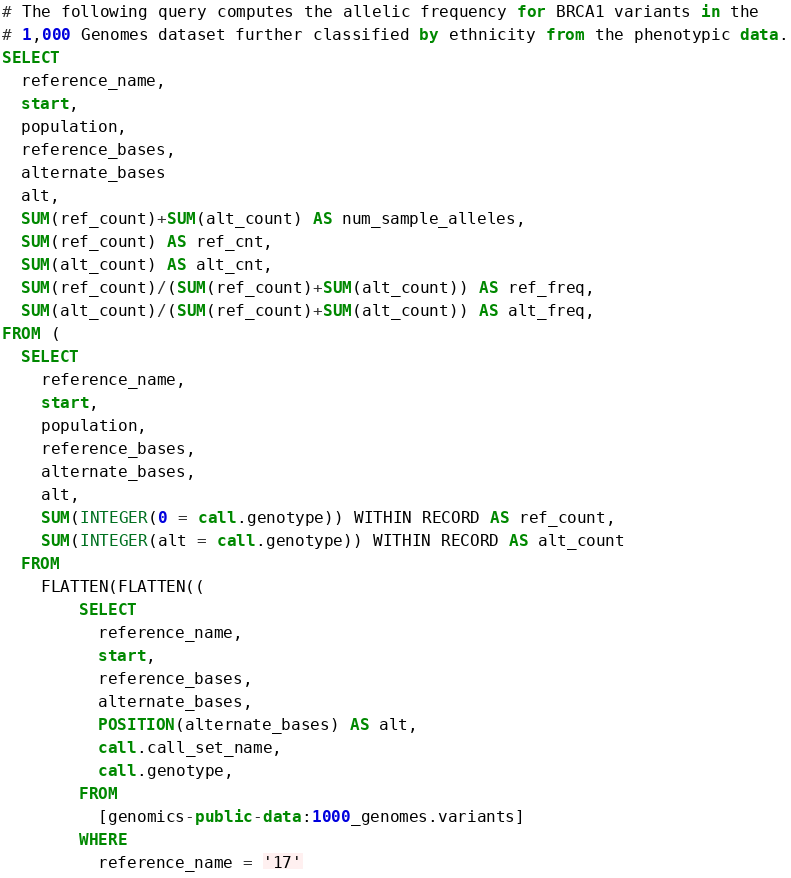Convert code to text. <code><loc_0><loc_0><loc_500><loc_500><_SQL_># The following query computes the allelic frequency for BRCA1 variants in the
# 1,000 Genomes dataset further classified by ethnicity from the phenotypic data.
SELECT
  reference_name,
  start,
  population,
  reference_bases,
  alternate_bases
  alt,
  SUM(ref_count)+SUM(alt_count) AS num_sample_alleles,
  SUM(ref_count) AS ref_cnt,
  SUM(alt_count) AS alt_cnt,
  SUM(ref_count)/(SUM(ref_count)+SUM(alt_count)) AS ref_freq,
  SUM(alt_count)/(SUM(ref_count)+SUM(alt_count)) AS alt_freq,
FROM (
  SELECT
    reference_name,
    start,
    population,
    reference_bases,
    alternate_bases,
    alt,
    SUM(INTEGER(0 = call.genotype)) WITHIN RECORD AS ref_count,
    SUM(INTEGER(alt = call.genotype)) WITHIN RECORD AS alt_count
  FROM
    FLATTEN(FLATTEN((
        SELECT
          reference_name,
          start,
          reference_bases,
          alternate_bases,
          POSITION(alternate_bases) AS alt,
          call.call_set_name,
          call.genotype,
        FROM
          [genomics-public-data:1000_genomes.variants]
        WHERE
          reference_name = '17'</code> 